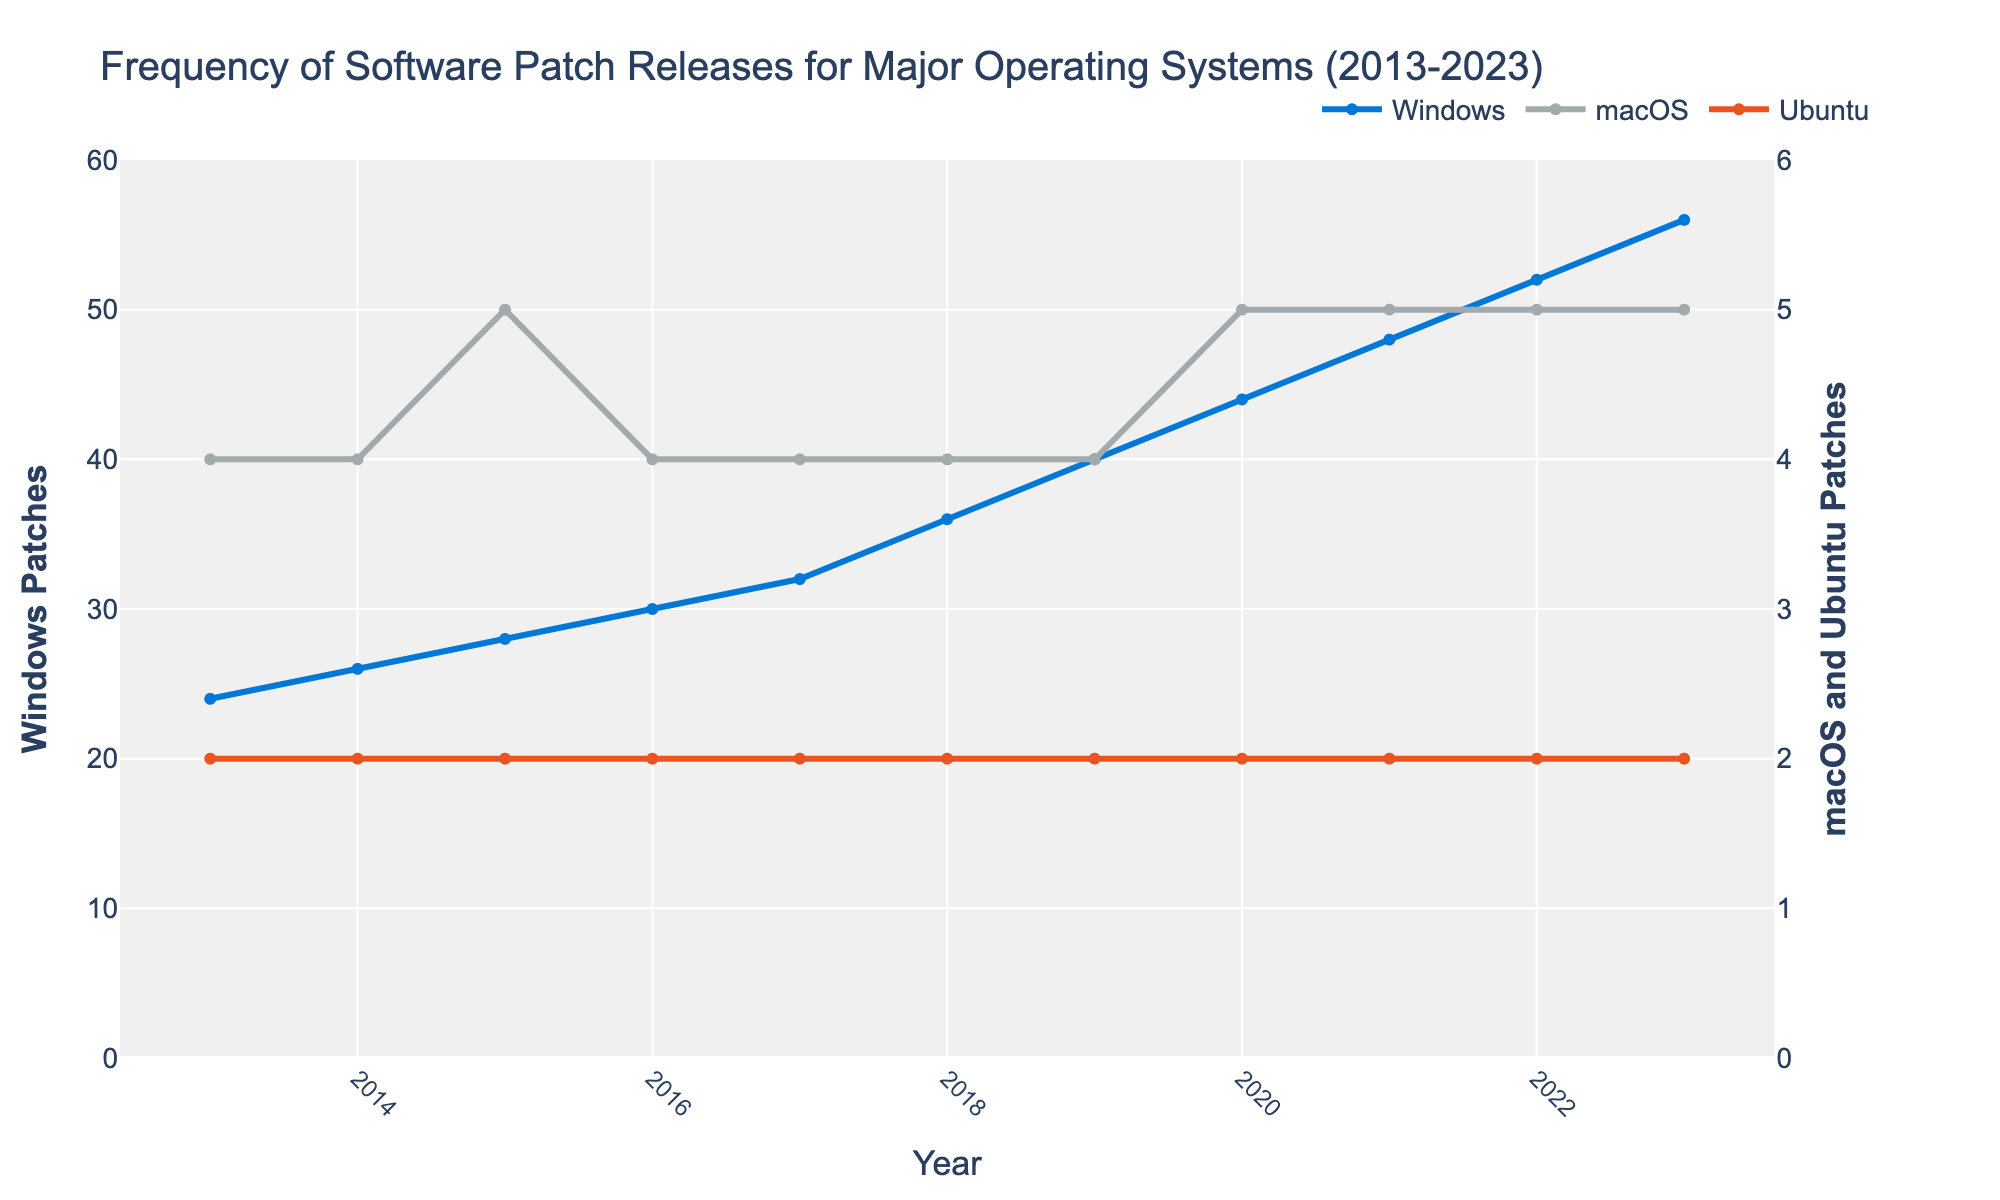What trend can you observe for the frequency of Windows patch releases over the decade? Examine the line representing Windows patches. It starts at 24 patches in 2013 and increases steadily each year, reaching 56 patches by 2023. This shows a consistent upward trend in the frequency of Windows patch releases over the past decade.
Answer: Steady upward trend How does the frequency of macOS patch releases in 2013 compare to that in 2023? Look at the starting and ending points of the macOS line. In 2013, there were 4 patches, and it slightly increased to 5 patches by 2023. This shows a minimal increase in the frequency of macOS patch releases over the decade.
Answer: Minimal increase Which operating system had the most consistent (unchanging) number of patch releases over the past decade? By observing all three lines, note that the line for Ubuntu remains flat over the years, with only 2 patches every year. This indicates that Ubuntu had the most consistent number of patch releases.
Answer: Ubuntu By how much did the frequency of Windows patch releases increase from 2013 to 2023? The Windows patch releases increased from 24 in 2013 to 56 in 2023. Calculate the difference: 56 - 24 = 32. Hence, the frequency increased by 32 patches.
Answer: 32 In which year did Windows surpass 40 patch releases? Check the Windows line to see when it first crosses the 40-patch mark. It is in 2019 when Windows released 40 patches. 2020 was the first year it had surpassed that mark with 44 patches.
Answer: 2020 What are the colors used to represent each operating system, and why is this useful? The colors are blue for Windows, gray for macOS, and orange for Ubuntu. Distinct colors help easily differentiate between the lines for each operating system, making the comparison straightforward.
Answer: Blue for Windows, gray for macOS, orange for Ubuntu Compare the macOS and Ubuntu patch releases in 2016. Which had more patches, and by how many? In 2016, both macOS and Ubuntu lines can be observed. macOS had 4 patches, whereas Ubuntu had 2 patches. Therefore, macOS had 2 more patches than Ubuntu.
Answer: macOS by 2 What was the average number of Windows patches released per year from 2013 to 2023? Sum the annual Windows patches from 2013 to 2023: (24 + 26 + 28 + 30 + 32 + 36 + 40 + 44 + 48 + 52 + 56) = 416. Divide this sum by 11 (number of years): 416 / 11 ≈ 37.82.
Answer: 37.82 Did any operating system have a year where no patches were released? Examine each line to see if any of them stay at zero at any point. None of the lines (Windows, macOS, or Ubuntu) touch zero, meaning all had patches released every year.
Answer: No What is the combined total of patches released by all operating systems in 2019? Sum the patches for all three operating systems in 2019. Windows: 40, macOS: 4, Ubuntu: 2. Total: 40 + 4 + 2 = 46.
Answer: 46 